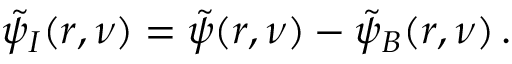Convert formula to latex. <formula><loc_0><loc_0><loc_500><loc_500>\tilde { \psi } _ { I } ( r , \nu ) = \tilde { \psi } ( r , \nu ) - \tilde { \psi } _ { B } ( r , \nu ) \, .</formula> 